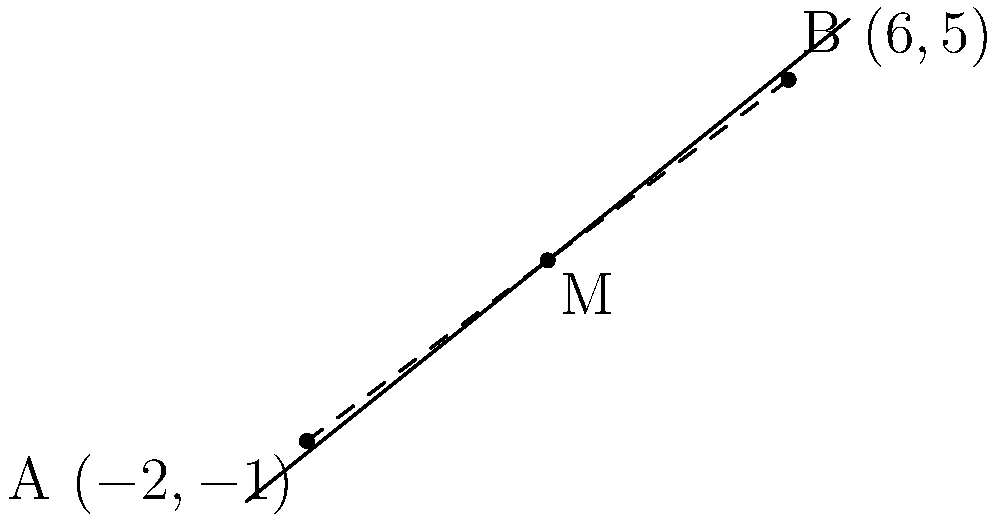At a Floorfiller music concert, two speakers are positioned at coordinates $A(-2,-1)$ and $B(6,5)$ in the venue. To ensure optimal sound distribution, you need to find the midpoint between these speakers. What are the coordinates of the midpoint $M$? To find the midpoint $M$ between two points $A(x_1, y_1)$ and $B(x_2, y_2)$, we use the midpoint formula:

$$M = (\frac{x_1 + x_2}{2}, \frac{y_1 + y_2}{2})$$

Given:
$A(-2,-1)$ and $B(6,5)$

Step 1: Calculate the x-coordinate of the midpoint:
$$x_M = \frac{x_1 + x_2}{2} = \frac{-2 + 6}{2} = \frac{4}{2} = 2$$

Step 2: Calculate the y-coordinate of the midpoint:
$$y_M = \frac{y_1 + y_2}{2} = \frac{-1 + 5}{2} = \frac{4}{2} = 2$$

Step 3: Combine the results to get the coordinates of the midpoint:
$M(2, 2)$
Answer: $M(2, 2)$ 